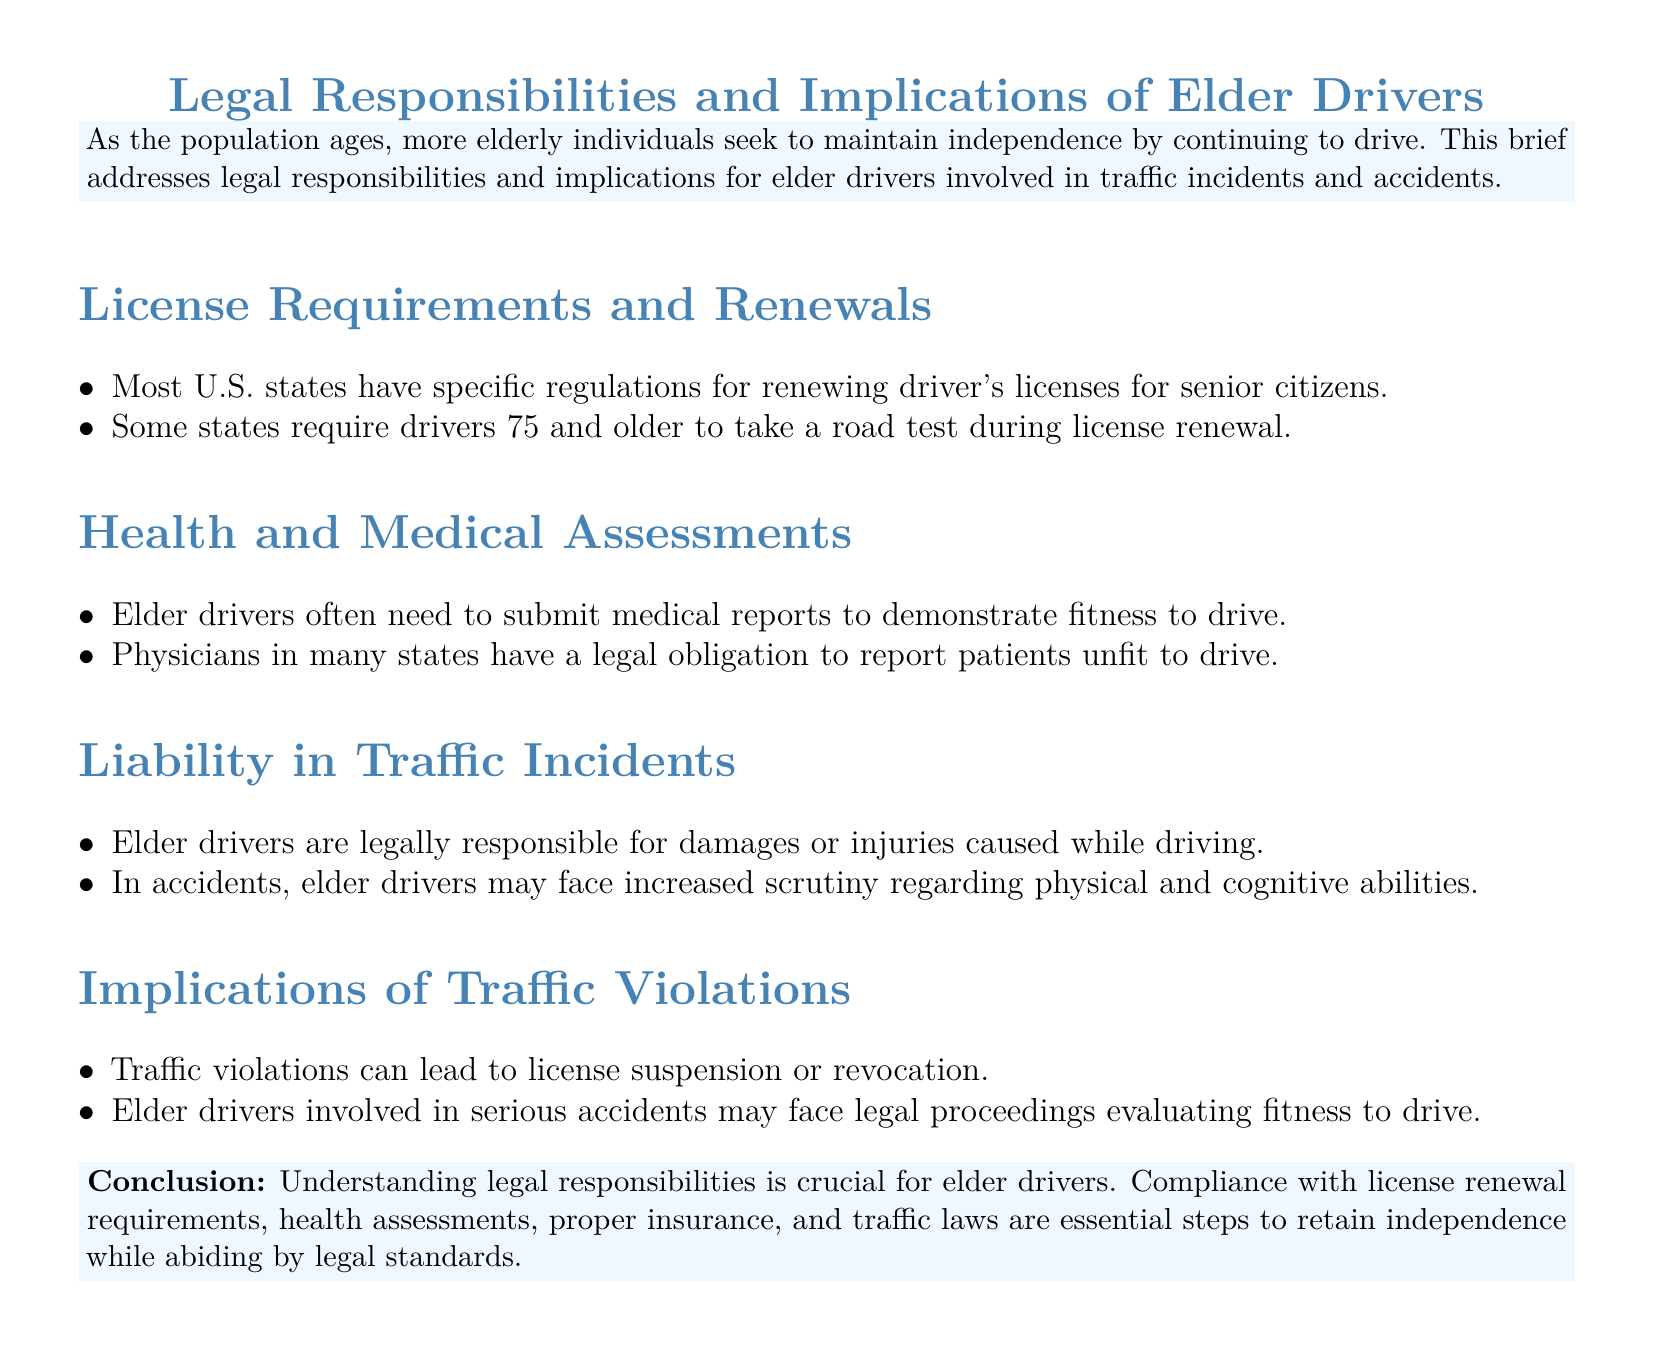What are the age requirements for a road test? The document states that some states require drivers 75 and older to take a road test during license renewal.
Answer: 75 What is necessary for elder drivers in certain states? The document mentions that elder drivers often need to submit medical reports to demonstrate fitness to drive.
Answer: Medical reports Who has a legal obligation to report unfit drivers? According to the document, physicians in many states have a legal obligation to report patients unfit to drive.
Answer: Physicians What are elder drivers legally responsible for? The document indicates that elder drivers are legally responsible for damages or injuries caused while driving.
Answer: Damages or injuries What can traffic violations lead to? The document states that traffic violations can lead to license suspension or revocation.
Answer: License suspension or revocation What may elder drivers face after serious accidents? The document mentions that elder drivers involved in serious accidents may face legal proceedings evaluating fitness to drive.
Answer: Legal proceedings What is crucial for elder drivers to understand? The document emphasizes that understanding legal responsibilities is crucial for elder drivers.
Answer: Legal responsibilities 